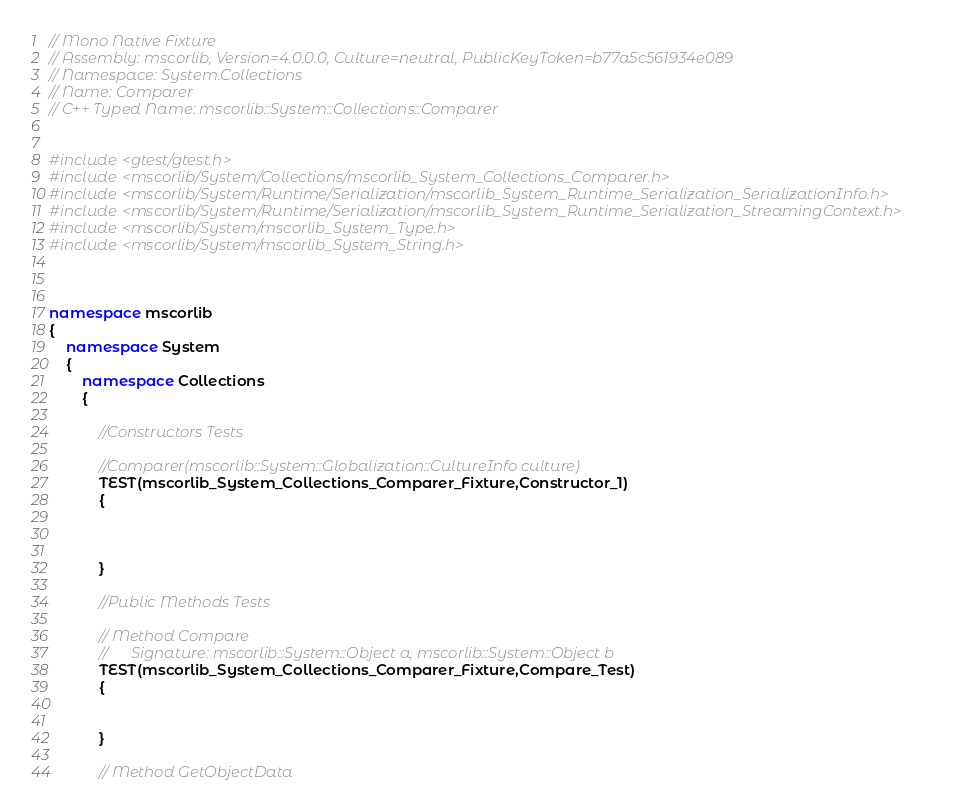<code> <loc_0><loc_0><loc_500><loc_500><_C++_>// Mono Native Fixture
// Assembly: mscorlib, Version=4.0.0.0, Culture=neutral, PublicKeyToken=b77a5c561934e089
// Namespace: System.Collections
// Name: Comparer
// C++ Typed Name: mscorlib::System::Collections::Comparer


#include <gtest/gtest.h>
#include <mscorlib/System/Collections/mscorlib_System_Collections_Comparer.h>
#include <mscorlib/System/Runtime/Serialization/mscorlib_System_Runtime_Serialization_SerializationInfo.h>
#include <mscorlib/System/Runtime/Serialization/mscorlib_System_Runtime_Serialization_StreamingContext.h>
#include <mscorlib/System/mscorlib_System_Type.h>
#include <mscorlib/System/mscorlib_System_String.h>



namespace mscorlib
{
	namespace System
	{
		namespace Collections
		{

			//Constructors Tests
			
			//Comparer(mscorlib::System::Globalization::CultureInfo culture)
			TEST(mscorlib_System_Collections_Comparer_Fixture,Constructor_1)
			{
				
				
				
			}
			
			//Public Methods Tests
			
			// Method Compare
			//		Signature: mscorlib::System::Object a, mscorlib::System::Object b
			TEST(mscorlib_System_Collections_Comparer_Fixture,Compare_Test)
			{
				
				
			}

			// Method GetObjectData</code> 